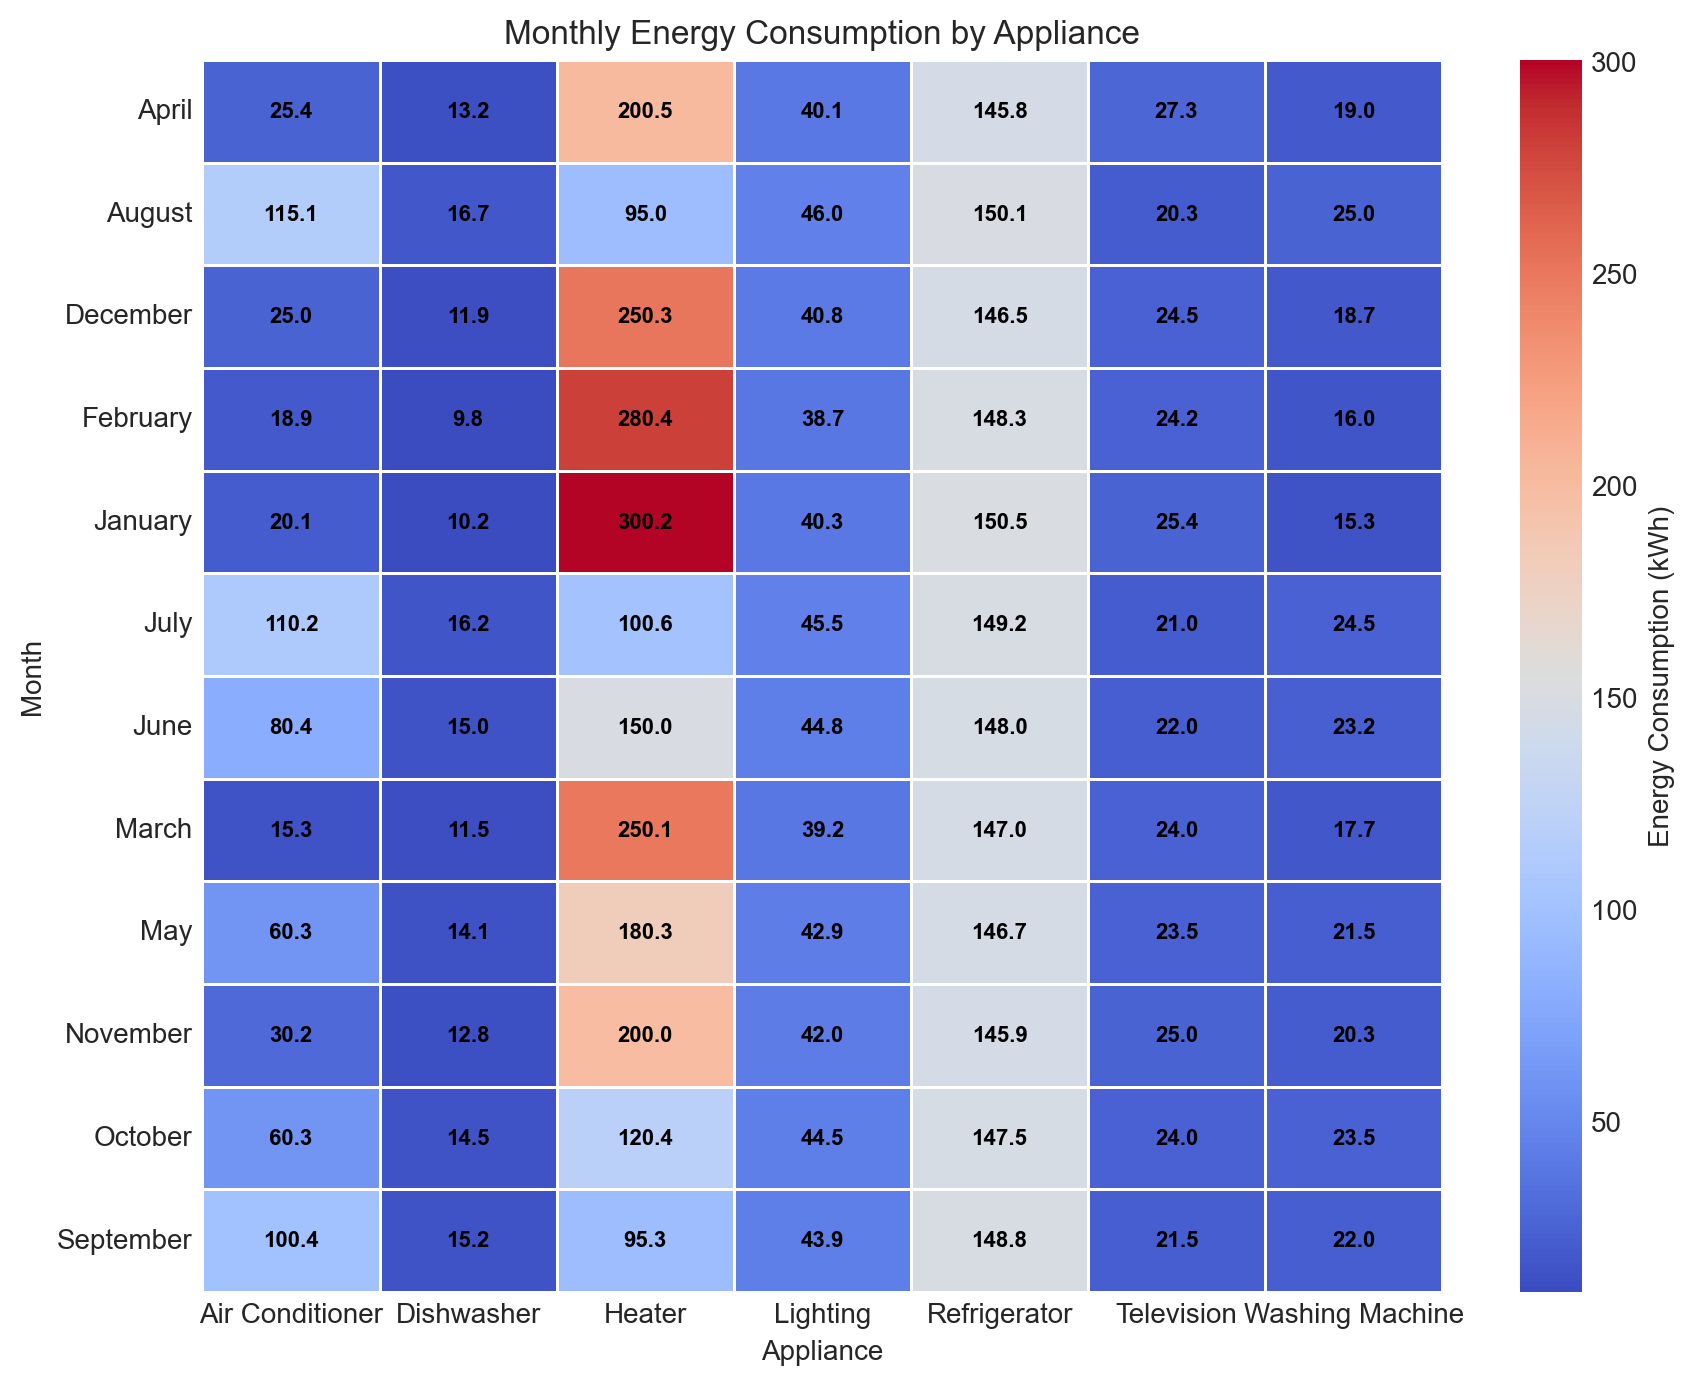What month has the highest energy consumption for Heaters? To determine the month with the highest energy consumption for Heaters, look for the highest value in the Heater column of the heatmap.
Answer: January Which appliance had the highest average energy consumption across all months? Average the energy consumption values for each appliance across all months, then compare the averages to find the highest.
Answer: Heater Which timezone shows the highest energy consumption for Air Conditioners in June? First, identify the energy consumption for Air Conditioners in June from the heatmap, then determine the corresponding timezone that shows this value.
Answer: CST During which month is the energy consumption for Refrigerators the least? Look for the lowest value in the Refrigerator column of the heatmap and note the corresponding month.
Answer: April Compare the energy consumption of Dishwashers in February and March. Which month has higher consumption? Locate the values for Dishwashers in February and March, then compare them to see which is higher.
Answer: March What is the total energy consumption of Washing Machines in PST timezone for January and February combined? Add the energy consumption values for Washing Machines in January and February within PST timezone.
Answer: 31.3 kWh For which month and appliance do we see the maximum overall energy consumption? Identify the cell with the highest value in the entire heatmap and note the corresponding month and appliance.
Answer: January, Heater Does Lighting have higher consumption in October or November? Compare the values for Lighting in October and November.
Answer: October What is the energy consumption difference between Air Conditioners in August and September in the PST timezone? Subtract the energy consumption value of Air Conditioners in September from that in August within the PST timezone.
Answer: 14.7 kWh Which appliance shows the highest increase in energy consumption between April and July in the MST timezone? Calculate the differences in energy consumption for each appliance between April and July, and identify the appliance with the highest increase.
Answer: Air Conditioner 